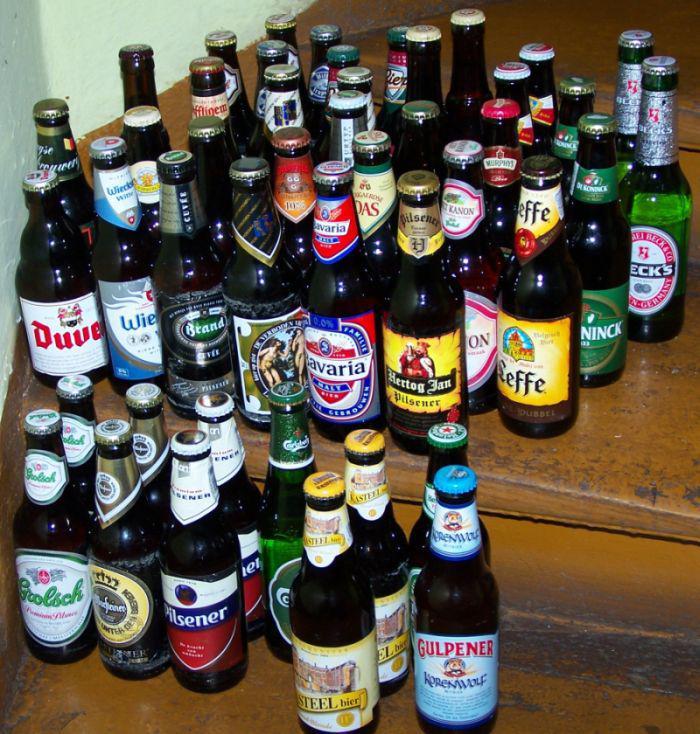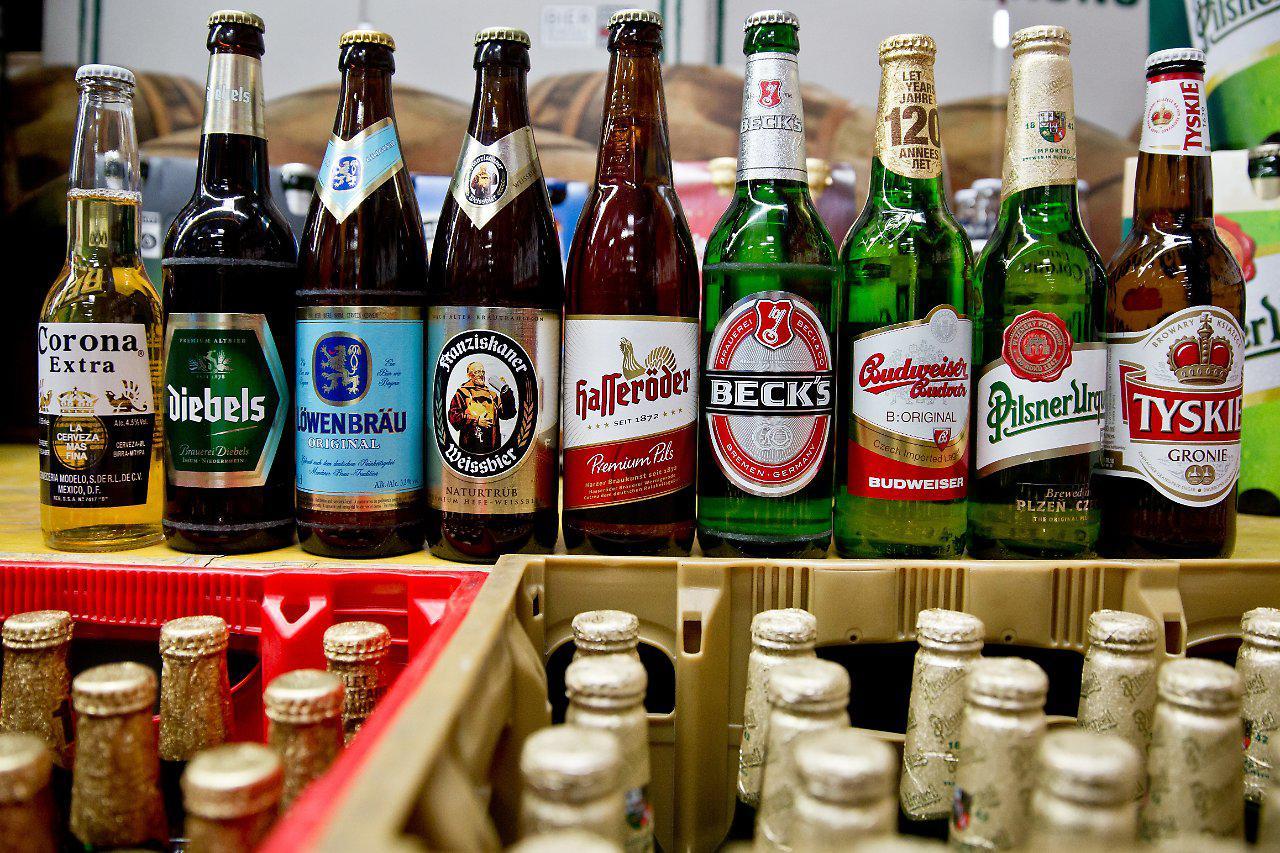The first image is the image on the left, the second image is the image on the right. For the images shown, is this caption "One image is a single dark brown glass bottle." true? Answer yes or no. No. 